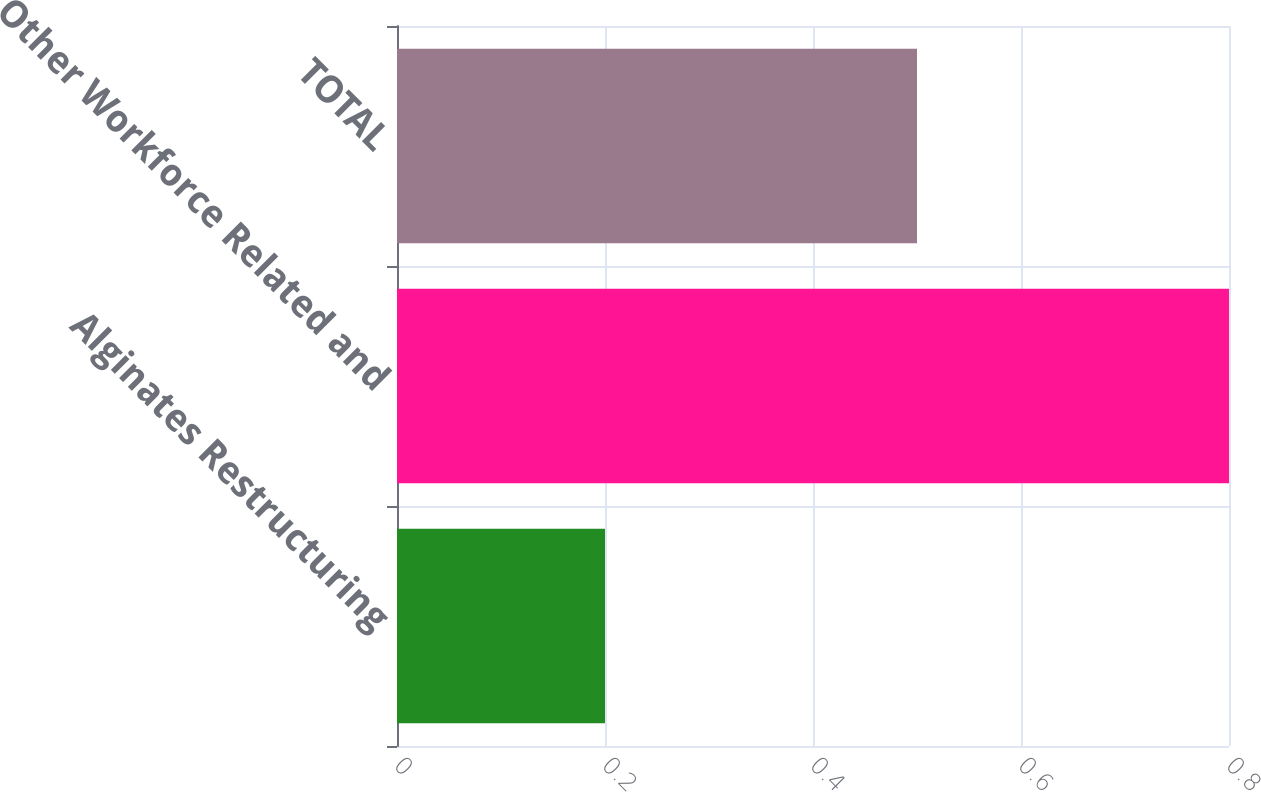Convert chart to OTSL. <chart><loc_0><loc_0><loc_500><loc_500><bar_chart><fcel>Alginates Restructuring<fcel>Other Workforce Related and<fcel>TOTAL<nl><fcel>0.2<fcel>0.8<fcel>0.5<nl></chart> 